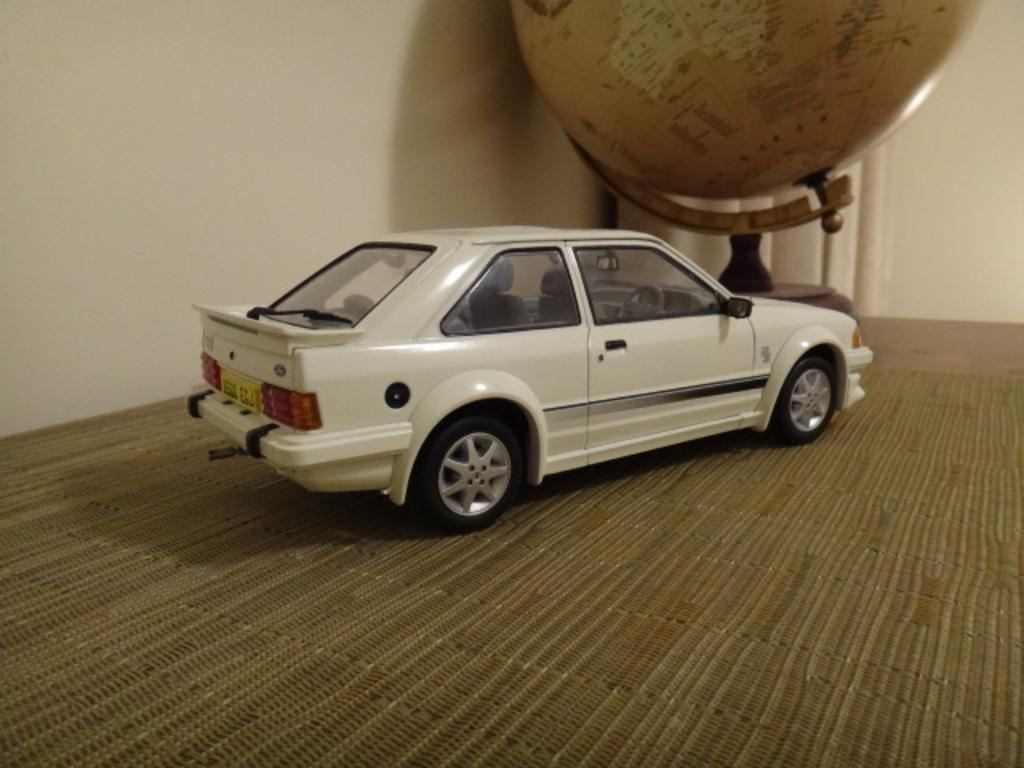How would you summarize this image in a sentence or two? There is a toy car kept on the table and in front of the car there is a globe,in the background there is a wall. 